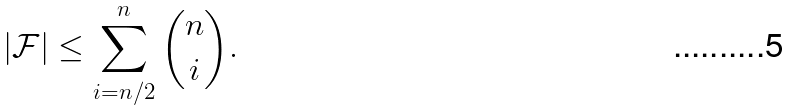Convert formula to latex. <formula><loc_0><loc_0><loc_500><loc_500>| \mathcal { F } | \leq \sum _ { i = n / 2 } ^ { n } { n \choose i } .</formula> 